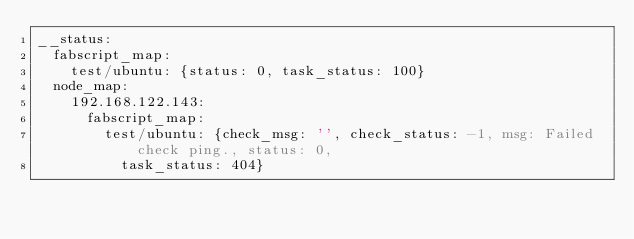<code> <loc_0><loc_0><loc_500><loc_500><_YAML_>__status:
  fabscript_map:
    test/ubuntu: {status: 0, task_status: 100}
  node_map:
    192.168.122.143:
      fabscript_map:
        test/ubuntu: {check_msg: '', check_status: -1, msg: Failed check ping., status: 0,
          task_status: 404}
</code> 